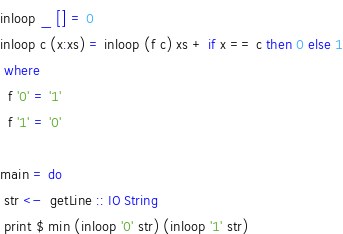<code> <loc_0><loc_0><loc_500><loc_500><_Haskell_>inloop _ [] = 0
inloop c (x:xs) = inloop (f c) xs + if x == c then 0 else 1
 where
  f '0' = '1'
  f '1' = '0'

main = do
 str <-  getLine :: IO String
 print $ min (inloop '0' str) (inloop '1' str)</code> 